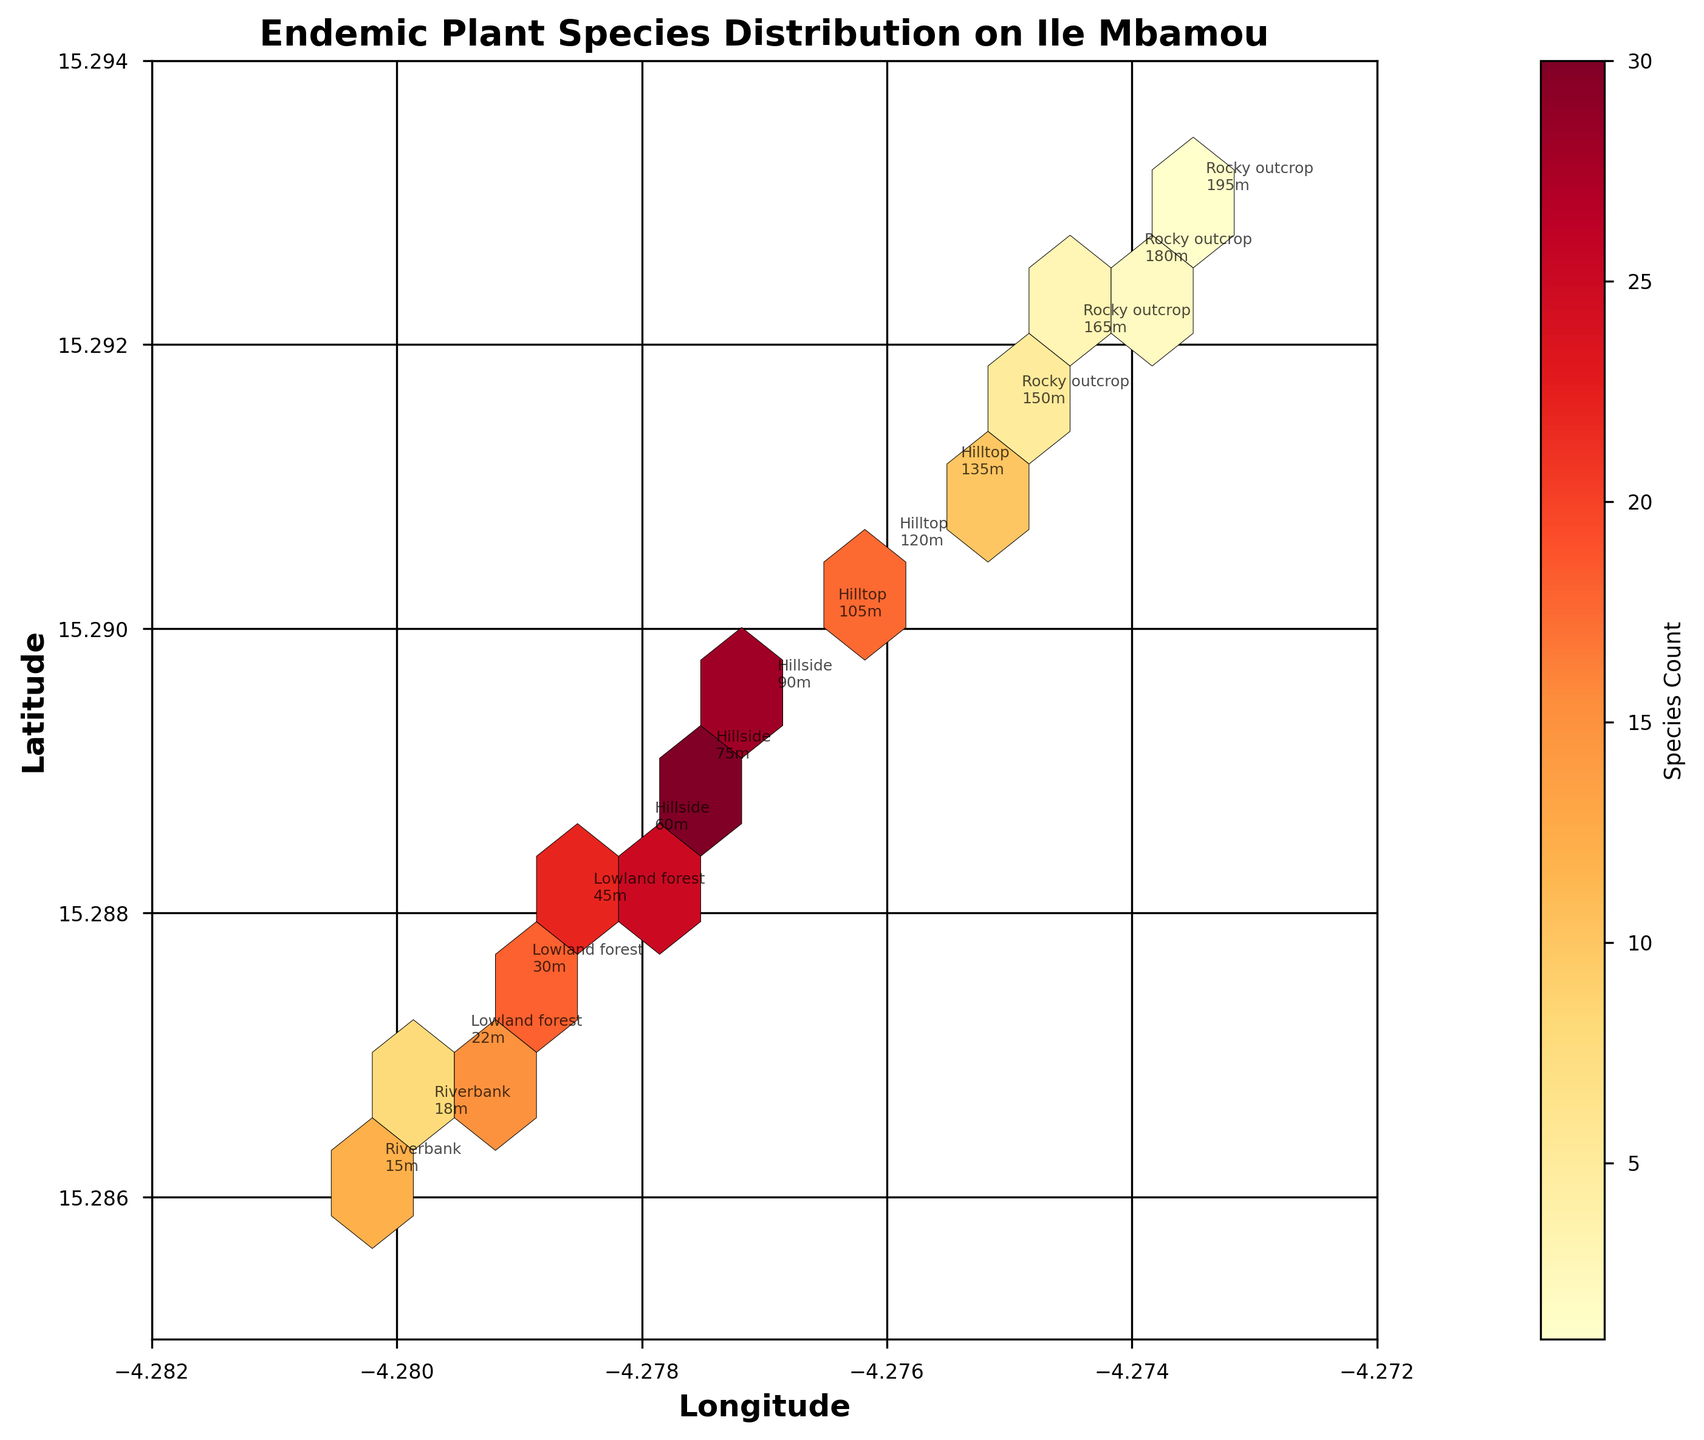what is the title of the hexbin plot? Look at the top of the figure where the title is displayed.
Answer: Endemic Plant Species Distribution on Ile Mbamou what is the range of species count represented by the color bar? Examine the color bar to determine the minimum and maximum values it displays.
Answer: 1 to 30 Which habitat is located at the lowest elevation? Look for annotations indicating habitat and elevation, then identify the lowest elevation value.
Answer: Riverbank what are the coordinates with the highest species count? Search for the hexbin with the darkest color, and note its coordinates.
Answer: (-4.2775, 15.2890) How does the species count change from riverbank to hilltop habitats? Observe the species count annotations on the hexbin plot for Riverbank and Hilltop habitat regions and compare them.
Answer: It increases from 12 to 30, then decreases to 10 Which hex showed the species count of 18? Find the hex annotated with a species count of 18 by verifying the coordinates.
Answer: (-4.2790, 15.2875) What is the common range of elevations for the lowland forest habitat? Look at the annotations for the lowland forest habitat and note the elevation range.
Answer: 22m to 45m Does the hillside have a higher or lower species count compared to the lowland forest? Compare the species count annotations of both habitats (Hillside and Lowland forest) to determine which is higher.
Answer: Higher Which habitat shows the most variation in species count? Identify the habitat with the largest range in species count by comparing all habitat regions annotated in the hexbin plot.
Answer: Hillside Which area has the densest clusters of species? Determine the area with the most densely packed hexagons, indicated by a clustering of colors.
Answer: Hillside 